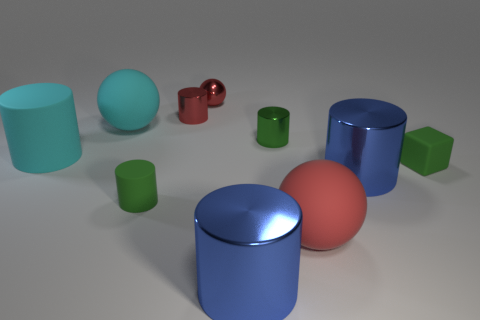Subtract 1 cylinders. How many cylinders are left? 5 Subtract all blue cylinders. How many cylinders are left? 4 Subtract all small green cylinders. How many cylinders are left? 4 Subtract all brown cylinders. Subtract all green cubes. How many cylinders are left? 6 Subtract all blocks. How many objects are left? 9 Add 5 big matte things. How many big matte things are left? 8 Add 9 large cyan matte balls. How many large cyan matte balls exist? 10 Subtract 0 brown cylinders. How many objects are left? 10 Subtract all big metallic cylinders. Subtract all large blue cylinders. How many objects are left? 6 